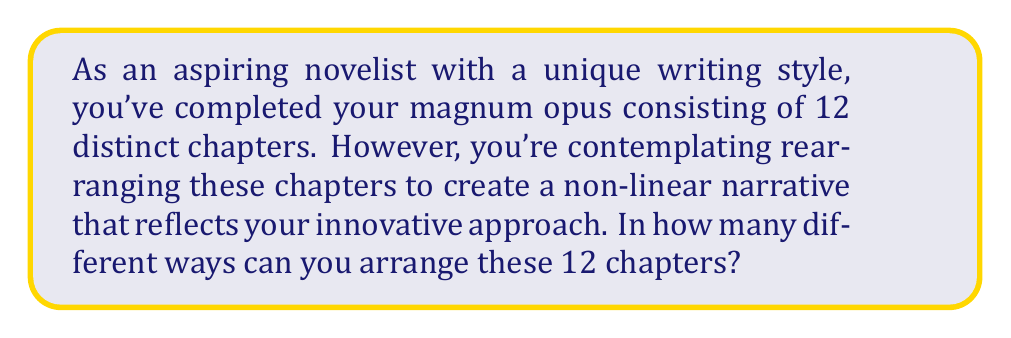Solve this math problem. To solve this problem, we need to consider the concept of permutations. A permutation is an arrangement of objects where order matters. In this case, each arrangement of the chapters represents a unique permutation.

Given:
- There are 12 distinct chapters
- All chapters must be used
- The order of the chapters matters

This scenario calls for a straightforward application of the permutation formula:

$$ P(n) = n! $$

Where:
$n$ is the number of distinct objects (in this case, chapters)
$!$ denotes the factorial operation

Step 1: Apply the permutation formula
$$ P(12) = 12! $$

Step 2: Calculate 12!
$$ 12! = 12 \times 11 \times 10 \times 9 \times 8 \times 7 \times 6 \times 5 \times 4 \times 3 \times 2 \times 1 $$

Step 3: Compute the final result
$$ 12! = 479,001,600 $$

Therefore, there are 479,001,600 different ways to arrange the 12 chapters of your novel.

This vast number of possibilities reflects the immense creative potential in structuring your narrative, aligning with your unique writing style and innovative approach to storytelling.
Answer: $479,001,600$ 